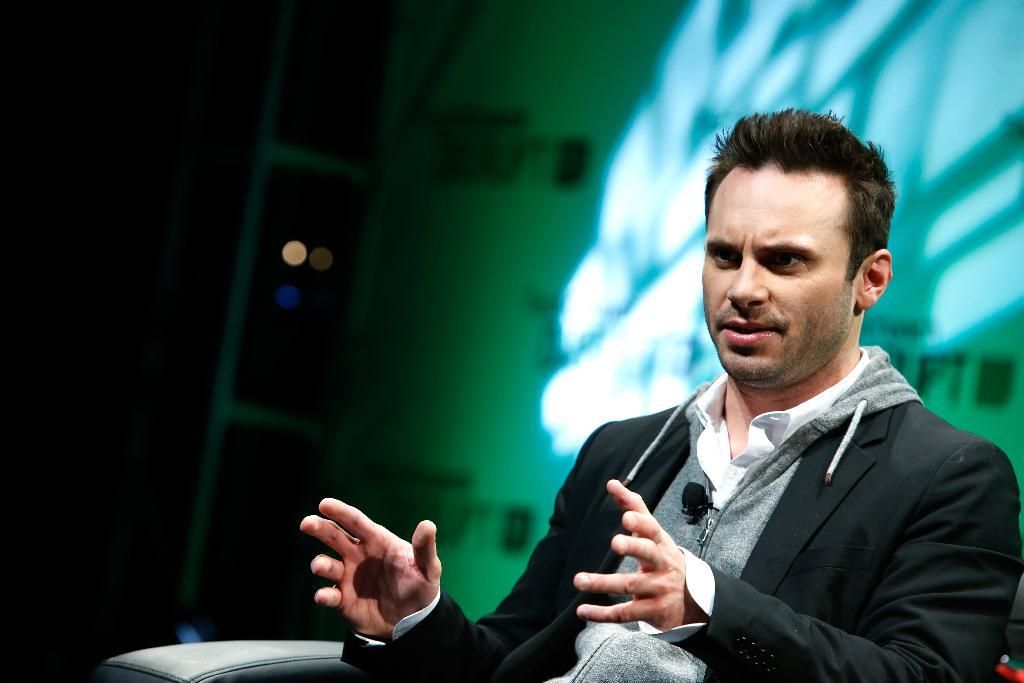Who or what can be seen in the image? There is a person in the image. What is the person doing in the image? The person is sitting on a chair. What else is present in the image besides the person? There is a banner in the image. Can you describe the banner in the image? The banner has text on it. What type of sound can be heard coming from the jam in the image? There is no jam present in the image, so it is not possible to determine what, if any, sound might be heard. 